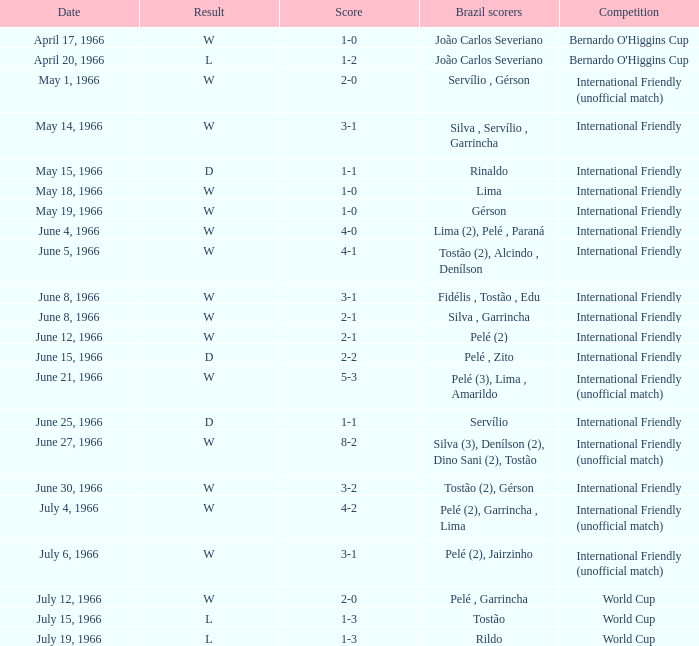What outcome occurs with a 4-0 score? W. 